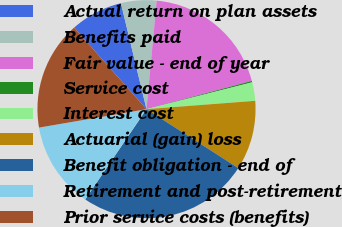Convert chart. <chart><loc_0><loc_0><loc_500><loc_500><pie_chart><fcel>Actual return on plan assets<fcel>Benefits paid<fcel>Fair value - end of year<fcel>Service cost<fcel>Interest cost<fcel>Actuarial (gain) loss<fcel>Benefit obligation - end of<fcel>Retirement and post-retirement<fcel>Prior service costs (benefits)<nl><fcel>7.78%<fcel>5.26%<fcel>19.33%<fcel>0.22%<fcel>2.74%<fcel>10.3%<fcel>25.41%<fcel>12.81%<fcel>16.15%<nl></chart> 